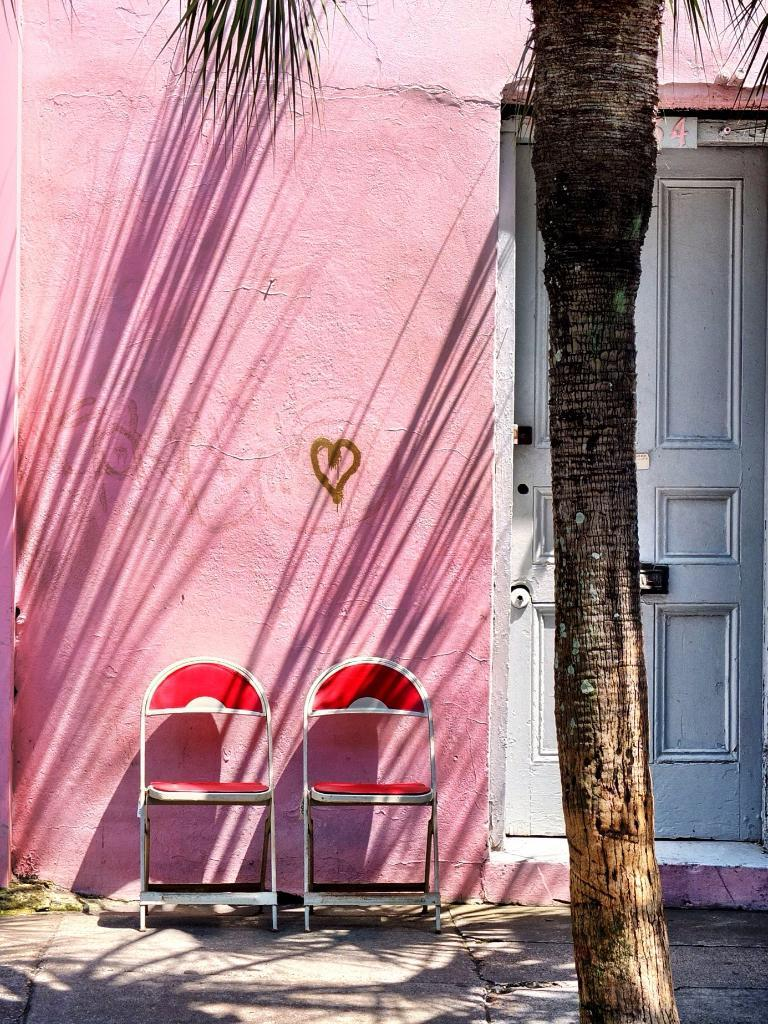What type of furniture is on the ground in the image? There are chairs on the ground in the image. What type of natural element is present in the image? There is a tree in the image. What type of man-made structure is present in the image? There is a wall in the image. What type of entrance is present in the image? There is a door in the image. What type of observation can be made about the crib in the image? There is no crib present in the image. What type of camp can be seen in the image? There is no camp present in the image. 